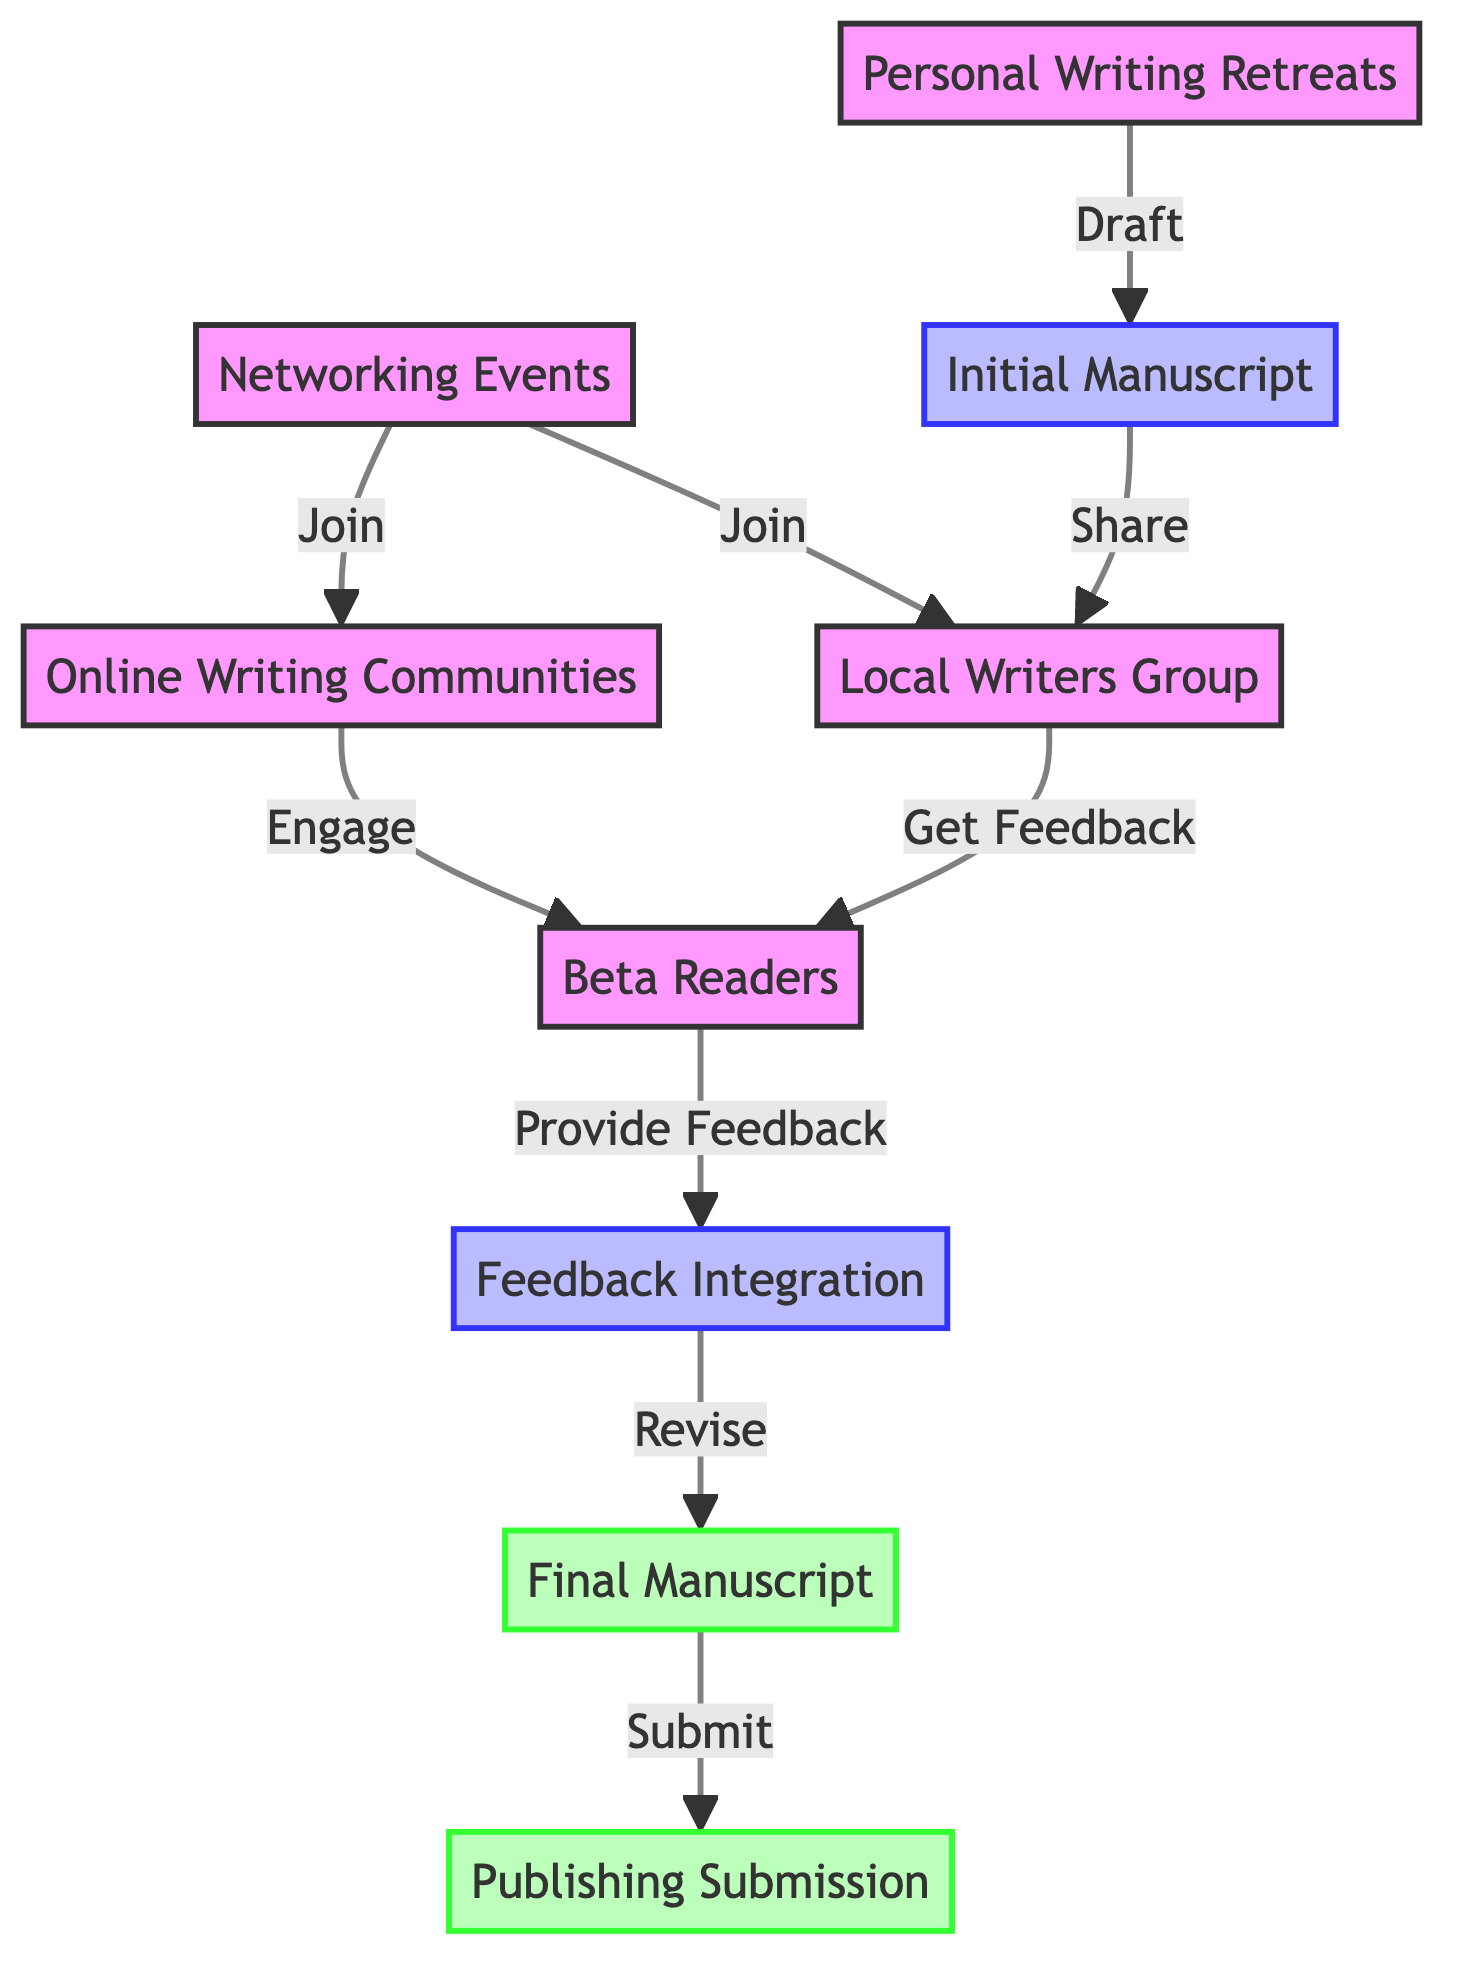What is the first step after Personal Writing Retreats? The arrow originating from Personal Writing Retreats points to the Initial Manuscript, indicating that the first action after personal writing retreats is to draft the initial manuscript.
Answer: Initial Manuscript How many nodes are in the diagram? By counting the nodes listed in the data, there are nine distinct nodes, each representing a part of the networking and beta reader feedback process.
Answer: 9 What is the role of Beta Readers in the process? The Beta Readers node receives input from the Local Writers Group and provides feedback to the Feedback Integration node, which indicates their role is to review the manuscript and provide constructive feedback.
Answer: Provide Feedback Which node follows Feedback Integration? The direct connection from Feedback Integration leads to the Final Manuscript, showing that the next step after integrating feedback is to finalize the manuscript.
Answer: Final Manuscript How do Online Writing Communities interact with Beta Readers? The Online Writing Communities node connects directly to the Beta Readers node through the edge labeled "Engage," which indicates that engagement with online communities is the way to reach the beta readers.
Answer: Engage What is the last step in the diagram? The edge leading from Final Manuscript to Publishing Submission shows that the last action in the process is to submit the finalized manuscript to publishers.
Answer: Publishing Submission How many edges are present in the diagram? By counting the connections (or edges) in the data, there are eight edges connecting the various nodes, illustrating the flow of the networking and feedback process.
Answer: 8 What node receives feedback from the Local Writers Group? The edge from the Local Writers Group to Beta Readers illustrates that the group provides feedback to the beta readers after reviewing the initial manuscript.
Answer: Beta Readers Which nodes represent outputs in the process? The nodes marked as outputs in the diagram are Final Manuscript and Publishing Submission, indicating these are the end results of the process.
Answer: Final Manuscript, Publishing Submission 